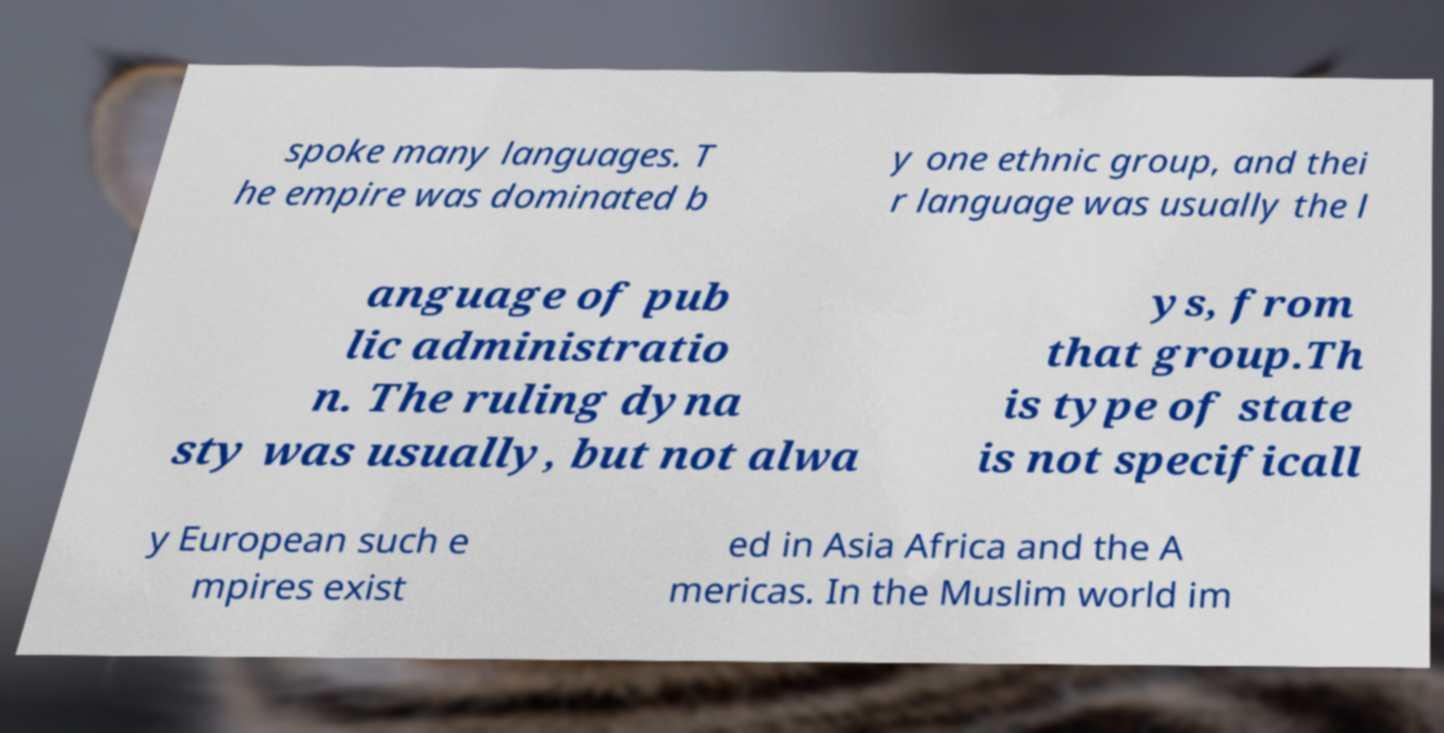Could you assist in decoding the text presented in this image and type it out clearly? spoke many languages. T he empire was dominated b y one ethnic group, and thei r language was usually the l anguage of pub lic administratio n. The ruling dyna sty was usually, but not alwa ys, from that group.Th is type of state is not specificall y European such e mpires exist ed in Asia Africa and the A mericas. In the Muslim world im 